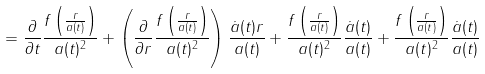Convert formula to latex. <formula><loc_0><loc_0><loc_500><loc_500>= \frac { \partial } { \partial t } \frac { f \left ( \frac { r } { a ( t ) } \right ) } { a ( t ) ^ { 2 } } + \left ( \frac { \partial } { \partial r } \frac { f \left ( \frac { r } { a ( t ) } \right ) } { a ( t ) ^ { 2 } } \right ) \frac { \dot { a } ( t ) r } { a ( t ) } + \frac { f \left ( \frac { r } { a ( t ) } \right ) } { a ( t ) ^ { 2 } } \frac { \dot { a } ( t ) } { a ( t ) } + \frac { f \left ( \frac { r } { a ( t ) } \right ) } { a ( t ) ^ { 2 } } \frac { \dot { a } ( t ) } { a ( t ) }</formula> 